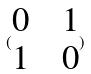Convert formula to latex. <formula><loc_0><loc_0><loc_500><loc_500>( \begin{matrix} 0 & & 1 \\ 1 & & 0 \end{matrix} )</formula> 